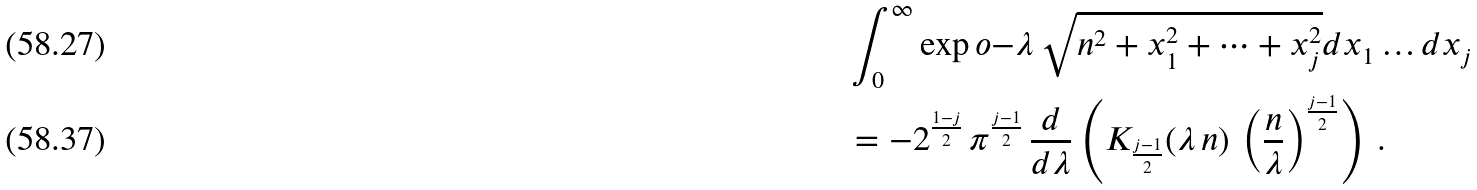<formula> <loc_0><loc_0><loc_500><loc_500>& \int _ { 0 } ^ { \infty } \exp o { - \lambda \, \sqrt { n ^ { 2 } + x _ { 1 } ^ { 2 } + \cdots + x _ { j } ^ { 2 } } } d x _ { 1 } \dots d x _ { j } \\ & = - 2 ^ { \frac { 1 - j } { 2 } } \, \pi ^ { \frac { j - 1 } { 2 } } \, \frac { d } { d \lambda } \left ( K _ { \frac { j - 1 } { 2 } } ( \lambda \, n ) \, \left ( \frac { n } { \lambda } \right ) ^ { \frac { j - 1 } { 2 } } \right ) \, .</formula> 